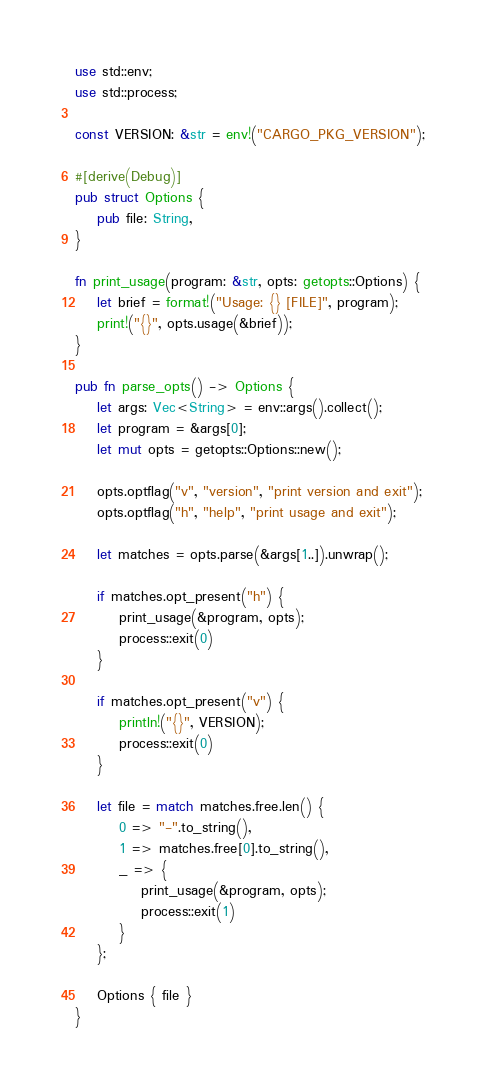Convert code to text. <code><loc_0><loc_0><loc_500><loc_500><_Rust_>use std::env;
use std::process;

const VERSION: &str = env!("CARGO_PKG_VERSION");

#[derive(Debug)]
pub struct Options {
    pub file: String,
}

fn print_usage(program: &str, opts: getopts::Options) {
    let brief = format!("Usage: {} [FILE]", program);
    print!("{}", opts.usage(&brief));
}

pub fn parse_opts() -> Options {
    let args: Vec<String> = env::args().collect();
    let program = &args[0];
    let mut opts = getopts::Options::new();

    opts.optflag("v", "version", "print version and exit");
    opts.optflag("h", "help", "print usage and exit");

    let matches = opts.parse(&args[1..]).unwrap();

    if matches.opt_present("h") {
        print_usage(&program, opts);
        process::exit(0)
    }

    if matches.opt_present("v") {
        println!("{}", VERSION);
        process::exit(0)
    }

    let file = match matches.free.len() {
        0 => "-".to_string(),
        1 => matches.free[0].to_string(),
        _ => {
            print_usage(&program, opts);
            process::exit(1)
        }
    };

    Options { file }
}</code> 